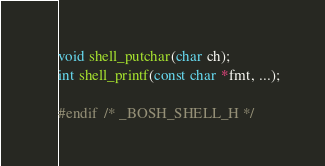Convert code to text. <code><loc_0><loc_0><loc_500><loc_500><_C_>void shell_putchar(char ch);
int shell_printf(const char *fmt, ...);

#endif  /* _BOSH_SHELL_H */</code> 